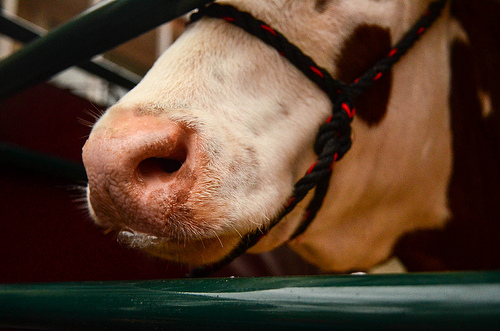<image>
Is there a cow in the bar? No. The cow is not contained within the bar. These objects have a different spatial relationship. 